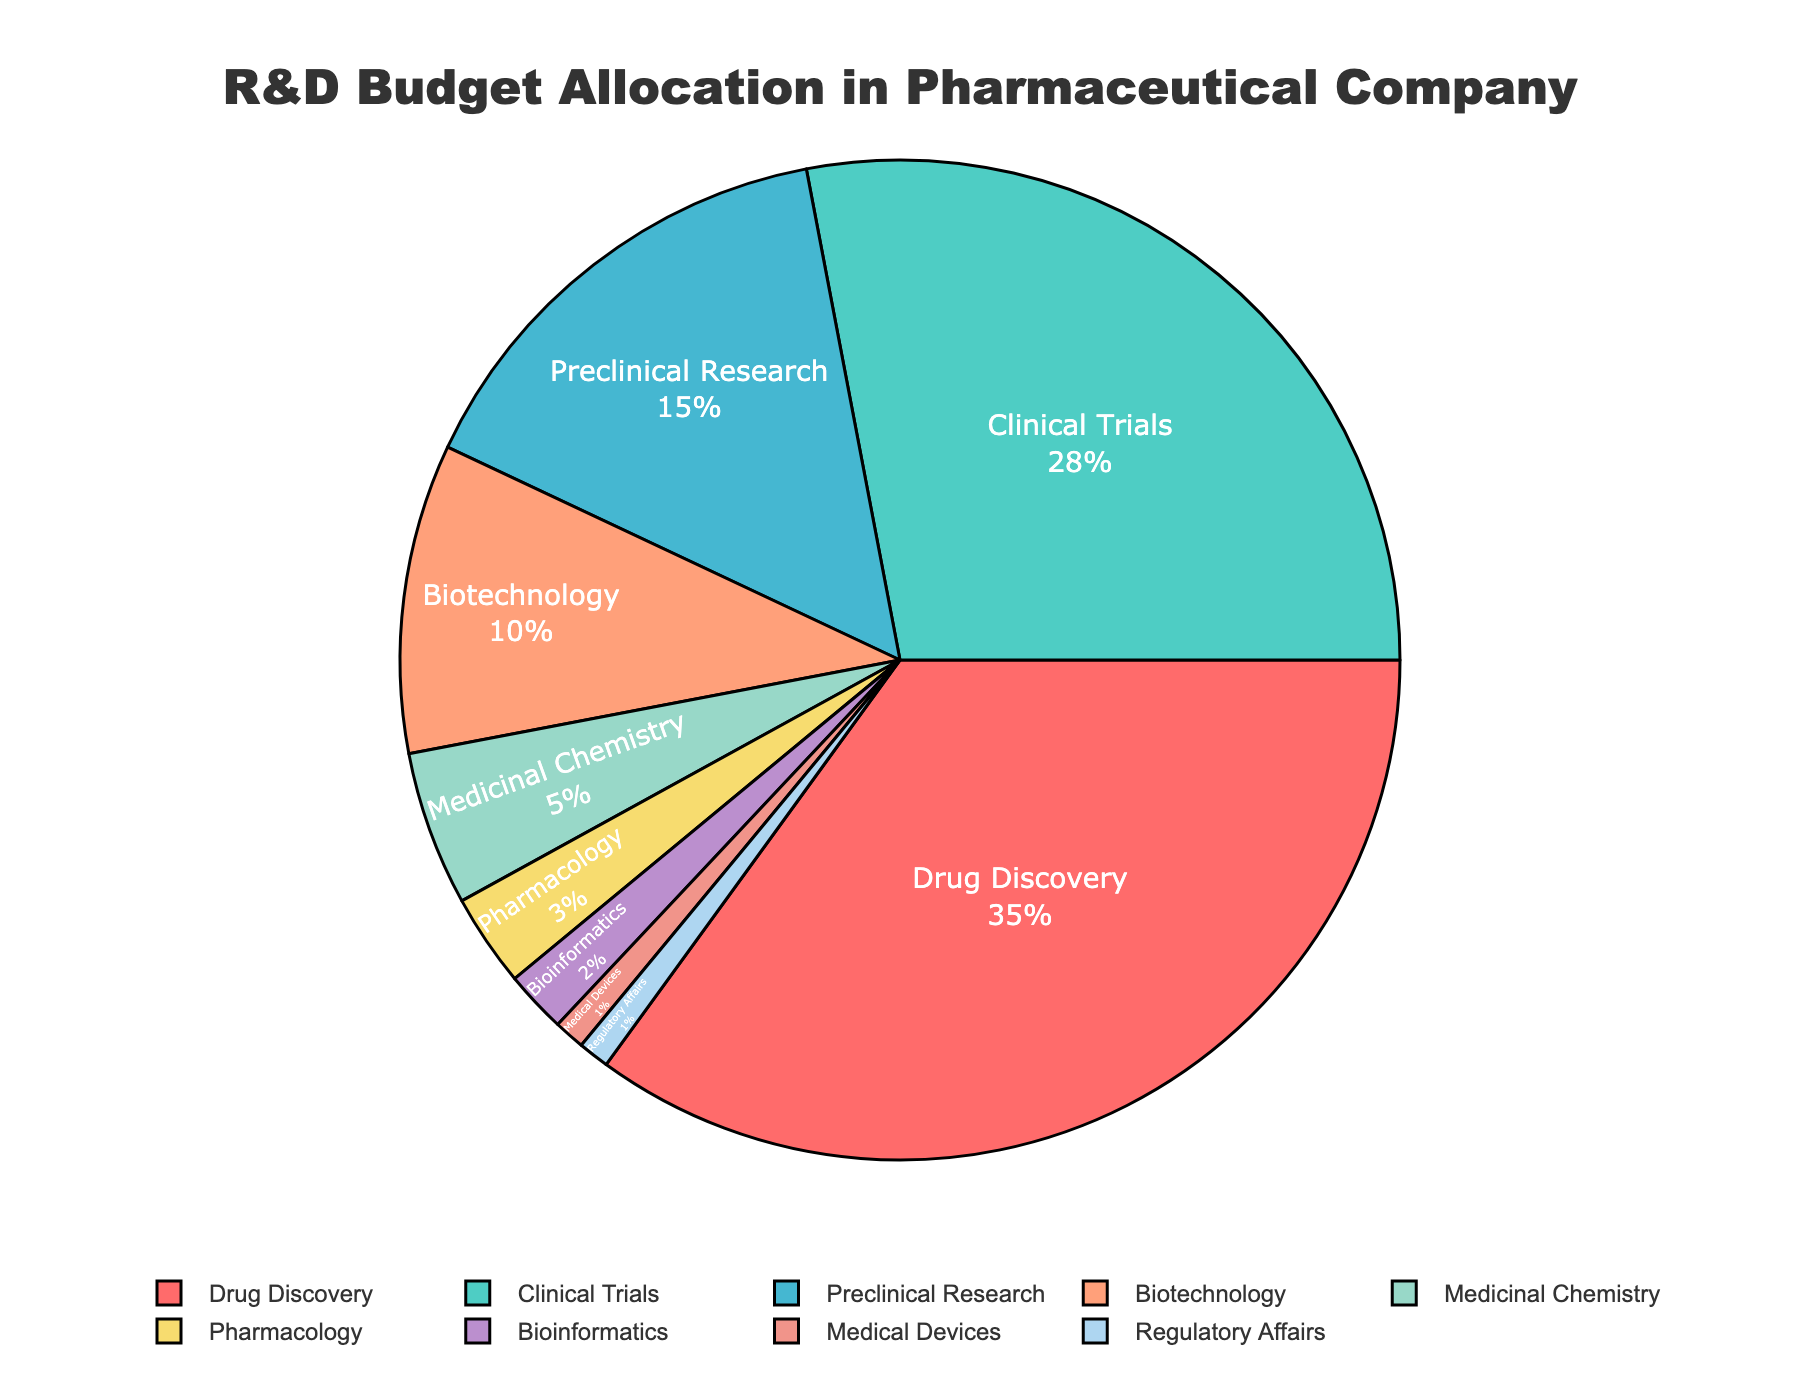What discipline receives the highest percentage of the R&D budget? The pie chart shows the distribution of the R&D budget among different scientific disciplines. By looking at the chart, Drug Discovery has the largest segment, indicating it receives the highest percentage.
Answer: Drug Discovery How much more R&D budget percentage does Biotechnology receive compared to Pharmacology? The chart indicates that Biotechnology receives 10% and Pharmacology receives 3%. The difference between them is 10% - 3% = 7%.
Answer: 7% What is the combined budget allocation for Clinical Trials and Preclinical Research? From the pie chart, Clinical Trials has 28% and Preclinical Research has 15%. Summing these values gives 28% + 15% = 43%.
Answer: 43% Which discipline has the smallest percentage of the R&D budget and what is the value? Observing the pie chart, both Medical Devices and Regulatory Affairs have the smallest segments, each representing 1% of the budget.
Answer: Medical Devices and Regulatory Affairs, 1% How does the budget allocation for Drug Discovery compare to the total budget for Biotechnology, Medicinal Chemistry, and Bioinformatics combined? The pie chart shows Drug Discovery with 35% of the budget. Biotechnology has 10%, Medicinal Chemistry has 5%, and Bioinformatics has 2%. Adding these up gives 10% + 5% + 2% = 17%. Drug Discovery's budget is 35%, which is 18% more than the combined budget for Biotechnology, Medicinal Chemistry, and Bioinformatics (35% - 17%).
Answer: 18% more What is the percentage difference between the budget allocations for Clinical Trials and Drug Discovery? The chart indicates that Clinical Trials has 28% and Drug Discovery has 35%. Their percentage difference is 35% - 28% = 7%.
Answer: 7% Which discipline receives 5% of the R&D budget and what is it labeled as in the pie chart? By examining the pie chart, Medicinal Chemistry accounts for 5% of the budget.
Answer: Medicinal Chemistry If we group Biomedical Informatics, Medical Devices, and Regulatory Affairs into one category "Others," what percentage of the R&D budget do they collectively have? According to the chart, Bioinformatics has 2%, Medical Devices has 1%, and Regulatory Affairs also has 1%. Adding these together: 2% + 1% + 1% = 4%.
Answer: 4% How do the budget allocations for Preclinical Research and Clinical Trials compare to each other in terms of percentage? From the pie chart, Preclinical Research has 15% and Clinical Trials has 28%. Clinical Trials receive 13% more of the budget than Preclinical Research (28% - 15%).
Answer: Clinical Trials receive 13% more What percentage of the budget does Biotechnology and Pharmacology combined receive and how does it compare to the budget for Preclinical Research? The pie chart shows Biotechnology with 10% and Pharmacology with 3%, giving a sum of 10% + 3% = 13%. Preclinical Research has 15%, which is 2% more than the combined total for Biotechnology and Pharmacology (15% - 13%).
Answer: 2% more 